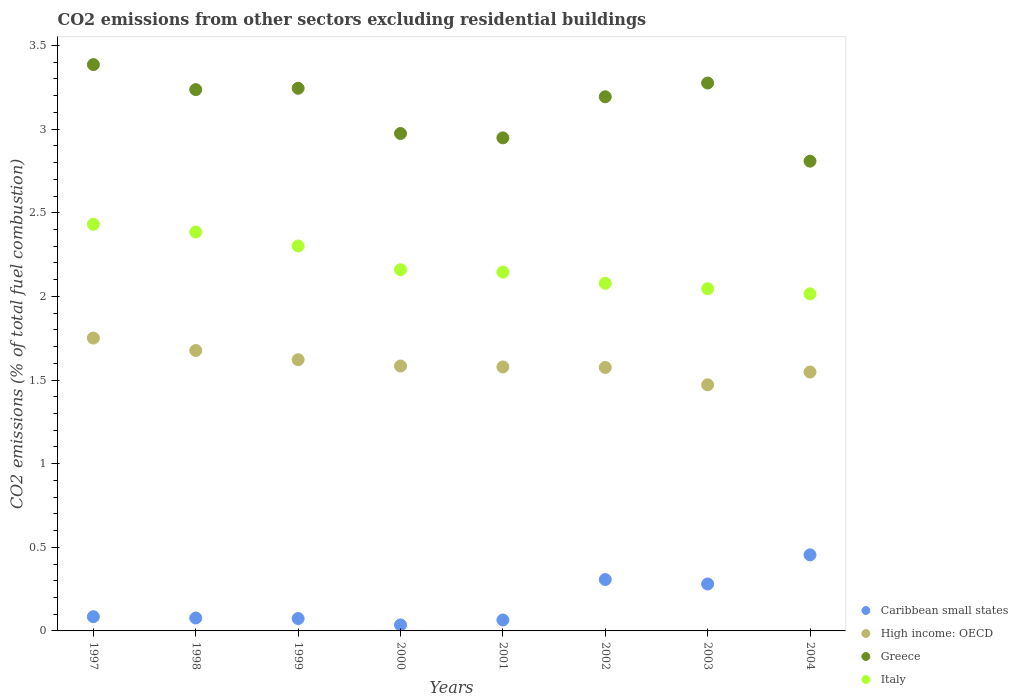Is the number of dotlines equal to the number of legend labels?
Offer a very short reply. Yes. What is the total CO2 emitted in Caribbean small states in 2001?
Provide a succinct answer. 0.07. Across all years, what is the maximum total CO2 emitted in Caribbean small states?
Provide a succinct answer. 0.45. Across all years, what is the minimum total CO2 emitted in Greece?
Your response must be concise. 2.81. In which year was the total CO2 emitted in Greece maximum?
Provide a succinct answer. 1997. In which year was the total CO2 emitted in Caribbean small states minimum?
Keep it short and to the point. 2000. What is the total total CO2 emitted in Greece in the graph?
Make the answer very short. 25.07. What is the difference between the total CO2 emitted in Greece in 2002 and that in 2003?
Offer a terse response. -0.08. What is the difference between the total CO2 emitted in High income: OECD in 1999 and the total CO2 emitted in Italy in 2000?
Ensure brevity in your answer.  -0.54. What is the average total CO2 emitted in High income: OECD per year?
Ensure brevity in your answer.  1.6. In the year 2004, what is the difference between the total CO2 emitted in High income: OECD and total CO2 emitted in Greece?
Keep it short and to the point. -1.26. What is the ratio of the total CO2 emitted in High income: OECD in 1998 to that in 2002?
Offer a terse response. 1.06. Is the difference between the total CO2 emitted in High income: OECD in 2000 and 2003 greater than the difference between the total CO2 emitted in Greece in 2000 and 2003?
Your answer should be very brief. Yes. What is the difference between the highest and the second highest total CO2 emitted in Italy?
Offer a very short reply. 0.05. What is the difference between the highest and the lowest total CO2 emitted in High income: OECD?
Ensure brevity in your answer.  0.28. Is the total CO2 emitted in Italy strictly less than the total CO2 emitted in High income: OECD over the years?
Provide a succinct answer. No. How many years are there in the graph?
Your answer should be compact. 8. Does the graph contain any zero values?
Provide a short and direct response. No. Does the graph contain grids?
Provide a short and direct response. No. Where does the legend appear in the graph?
Your answer should be compact. Bottom right. How are the legend labels stacked?
Offer a terse response. Vertical. What is the title of the graph?
Provide a short and direct response. CO2 emissions from other sectors excluding residential buildings. What is the label or title of the X-axis?
Give a very brief answer. Years. What is the label or title of the Y-axis?
Your response must be concise. CO2 emissions (% of total fuel combustion). What is the CO2 emissions (% of total fuel combustion) in Caribbean small states in 1997?
Make the answer very short. 0.08. What is the CO2 emissions (% of total fuel combustion) of High income: OECD in 1997?
Your answer should be very brief. 1.75. What is the CO2 emissions (% of total fuel combustion) of Greece in 1997?
Give a very brief answer. 3.39. What is the CO2 emissions (% of total fuel combustion) of Italy in 1997?
Make the answer very short. 2.43. What is the CO2 emissions (% of total fuel combustion) in Caribbean small states in 1998?
Provide a succinct answer. 0.08. What is the CO2 emissions (% of total fuel combustion) of High income: OECD in 1998?
Offer a terse response. 1.68. What is the CO2 emissions (% of total fuel combustion) of Greece in 1998?
Give a very brief answer. 3.24. What is the CO2 emissions (% of total fuel combustion) of Italy in 1998?
Keep it short and to the point. 2.38. What is the CO2 emissions (% of total fuel combustion) of Caribbean small states in 1999?
Your answer should be very brief. 0.07. What is the CO2 emissions (% of total fuel combustion) of High income: OECD in 1999?
Offer a terse response. 1.62. What is the CO2 emissions (% of total fuel combustion) in Greece in 1999?
Your response must be concise. 3.24. What is the CO2 emissions (% of total fuel combustion) of Italy in 1999?
Provide a short and direct response. 2.3. What is the CO2 emissions (% of total fuel combustion) of Caribbean small states in 2000?
Your answer should be compact. 0.04. What is the CO2 emissions (% of total fuel combustion) of High income: OECD in 2000?
Provide a succinct answer. 1.58. What is the CO2 emissions (% of total fuel combustion) of Greece in 2000?
Offer a very short reply. 2.97. What is the CO2 emissions (% of total fuel combustion) of Italy in 2000?
Offer a very short reply. 2.16. What is the CO2 emissions (% of total fuel combustion) in Caribbean small states in 2001?
Your response must be concise. 0.07. What is the CO2 emissions (% of total fuel combustion) of High income: OECD in 2001?
Offer a very short reply. 1.58. What is the CO2 emissions (% of total fuel combustion) in Greece in 2001?
Keep it short and to the point. 2.95. What is the CO2 emissions (% of total fuel combustion) in Italy in 2001?
Offer a very short reply. 2.15. What is the CO2 emissions (% of total fuel combustion) in Caribbean small states in 2002?
Your response must be concise. 0.31. What is the CO2 emissions (% of total fuel combustion) in High income: OECD in 2002?
Give a very brief answer. 1.58. What is the CO2 emissions (% of total fuel combustion) in Greece in 2002?
Make the answer very short. 3.19. What is the CO2 emissions (% of total fuel combustion) of Italy in 2002?
Provide a short and direct response. 2.08. What is the CO2 emissions (% of total fuel combustion) of Caribbean small states in 2003?
Your answer should be very brief. 0.28. What is the CO2 emissions (% of total fuel combustion) of High income: OECD in 2003?
Provide a short and direct response. 1.47. What is the CO2 emissions (% of total fuel combustion) of Greece in 2003?
Give a very brief answer. 3.28. What is the CO2 emissions (% of total fuel combustion) in Italy in 2003?
Your response must be concise. 2.05. What is the CO2 emissions (% of total fuel combustion) of Caribbean small states in 2004?
Provide a short and direct response. 0.45. What is the CO2 emissions (% of total fuel combustion) of High income: OECD in 2004?
Offer a terse response. 1.55. What is the CO2 emissions (% of total fuel combustion) of Greece in 2004?
Provide a short and direct response. 2.81. What is the CO2 emissions (% of total fuel combustion) in Italy in 2004?
Your answer should be very brief. 2.02. Across all years, what is the maximum CO2 emissions (% of total fuel combustion) in Caribbean small states?
Offer a very short reply. 0.45. Across all years, what is the maximum CO2 emissions (% of total fuel combustion) in High income: OECD?
Offer a very short reply. 1.75. Across all years, what is the maximum CO2 emissions (% of total fuel combustion) of Greece?
Ensure brevity in your answer.  3.39. Across all years, what is the maximum CO2 emissions (% of total fuel combustion) in Italy?
Make the answer very short. 2.43. Across all years, what is the minimum CO2 emissions (% of total fuel combustion) in Caribbean small states?
Provide a short and direct response. 0.04. Across all years, what is the minimum CO2 emissions (% of total fuel combustion) in High income: OECD?
Your answer should be very brief. 1.47. Across all years, what is the minimum CO2 emissions (% of total fuel combustion) in Greece?
Ensure brevity in your answer.  2.81. Across all years, what is the minimum CO2 emissions (% of total fuel combustion) in Italy?
Your answer should be compact. 2.02. What is the total CO2 emissions (% of total fuel combustion) of Caribbean small states in the graph?
Give a very brief answer. 1.38. What is the total CO2 emissions (% of total fuel combustion) of High income: OECD in the graph?
Your response must be concise. 12.81. What is the total CO2 emissions (% of total fuel combustion) in Greece in the graph?
Offer a terse response. 25.07. What is the total CO2 emissions (% of total fuel combustion) in Italy in the graph?
Provide a succinct answer. 17.56. What is the difference between the CO2 emissions (% of total fuel combustion) in Caribbean small states in 1997 and that in 1998?
Offer a very short reply. 0.01. What is the difference between the CO2 emissions (% of total fuel combustion) in High income: OECD in 1997 and that in 1998?
Keep it short and to the point. 0.07. What is the difference between the CO2 emissions (% of total fuel combustion) in Greece in 1997 and that in 1998?
Give a very brief answer. 0.15. What is the difference between the CO2 emissions (% of total fuel combustion) of Italy in 1997 and that in 1998?
Your answer should be very brief. 0.05. What is the difference between the CO2 emissions (% of total fuel combustion) of Caribbean small states in 1997 and that in 1999?
Offer a terse response. 0.01. What is the difference between the CO2 emissions (% of total fuel combustion) of High income: OECD in 1997 and that in 1999?
Offer a very short reply. 0.13. What is the difference between the CO2 emissions (% of total fuel combustion) in Greece in 1997 and that in 1999?
Give a very brief answer. 0.14. What is the difference between the CO2 emissions (% of total fuel combustion) in Italy in 1997 and that in 1999?
Make the answer very short. 0.13. What is the difference between the CO2 emissions (% of total fuel combustion) in Caribbean small states in 1997 and that in 2000?
Offer a terse response. 0.05. What is the difference between the CO2 emissions (% of total fuel combustion) in High income: OECD in 1997 and that in 2000?
Make the answer very short. 0.17. What is the difference between the CO2 emissions (% of total fuel combustion) of Greece in 1997 and that in 2000?
Make the answer very short. 0.41. What is the difference between the CO2 emissions (% of total fuel combustion) in Italy in 1997 and that in 2000?
Provide a succinct answer. 0.27. What is the difference between the CO2 emissions (% of total fuel combustion) in Caribbean small states in 1997 and that in 2001?
Your response must be concise. 0.02. What is the difference between the CO2 emissions (% of total fuel combustion) in High income: OECD in 1997 and that in 2001?
Provide a succinct answer. 0.17. What is the difference between the CO2 emissions (% of total fuel combustion) of Greece in 1997 and that in 2001?
Make the answer very short. 0.44. What is the difference between the CO2 emissions (% of total fuel combustion) of Italy in 1997 and that in 2001?
Make the answer very short. 0.29. What is the difference between the CO2 emissions (% of total fuel combustion) of Caribbean small states in 1997 and that in 2002?
Ensure brevity in your answer.  -0.22. What is the difference between the CO2 emissions (% of total fuel combustion) of High income: OECD in 1997 and that in 2002?
Offer a terse response. 0.18. What is the difference between the CO2 emissions (% of total fuel combustion) in Greece in 1997 and that in 2002?
Provide a succinct answer. 0.19. What is the difference between the CO2 emissions (% of total fuel combustion) of Italy in 1997 and that in 2002?
Offer a terse response. 0.35. What is the difference between the CO2 emissions (% of total fuel combustion) of Caribbean small states in 1997 and that in 2003?
Ensure brevity in your answer.  -0.2. What is the difference between the CO2 emissions (% of total fuel combustion) of High income: OECD in 1997 and that in 2003?
Provide a succinct answer. 0.28. What is the difference between the CO2 emissions (% of total fuel combustion) in Greece in 1997 and that in 2003?
Make the answer very short. 0.11. What is the difference between the CO2 emissions (% of total fuel combustion) in Italy in 1997 and that in 2003?
Keep it short and to the point. 0.38. What is the difference between the CO2 emissions (% of total fuel combustion) in Caribbean small states in 1997 and that in 2004?
Keep it short and to the point. -0.37. What is the difference between the CO2 emissions (% of total fuel combustion) of High income: OECD in 1997 and that in 2004?
Provide a succinct answer. 0.2. What is the difference between the CO2 emissions (% of total fuel combustion) of Greece in 1997 and that in 2004?
Provide a short and direct response. 0.58. What is the difference between the CO2 emissions (% of total fuel combustion) of Italy in 1997 and that in 2004?
Keep it short and to the point. 0.42. What is the difference between the CO2 emissions (% of total fuel combustion) of Caribbean small states in 1998 and that in 1999?
Provide a short and direct response. 0. What is the difference between the CO2 emissions (% of total fuel combustion) in High income: OECD in 1998 and that in 1999?
Ensure brevity in your answer.  0.06. What is the difference between the CO2 emissions (% of total fuel combustion) of Greece in 1998 and that in 1999?
Ensure brevity in your answer.  -0.01. What is the difference between the CO2 emissions (% of total fuel combustion) in Italy in 1998 and that in 1999?
Make the answer very short. 0.08. What is the difference between the CO2 emissions (% of total fuel combustion) in Caribbean small states in 1998 and that in 2000?
Offer a terse response. 0.04. What is the difference between the CO2 emissions (% of total fuel combustion) of High income: OECD in 1998 and that in 2000?
Your answer should be very brief. 0.09. What is the difference between the CO2 emissions (% of total fuel combustion) of Greece in 1998 and that in 2000?
Make the answer very short. 0.26. What is the difference between the CO2 emissions (% of total fuel combustion) of Italy in 1998 and that in 2000?
Give a very brief answer. 0.23. What is the difference between the CO2 emissions (% of total fuel combustion) in Caribbean small states in 1998 and that in 2001?
Keep it short and to the point. 0.01. What is the difference between the CO2 emissions (% of total fuel combustion) in High income: OECD in 1998 and that in 2001?
Your response must be concise. 0.1. What is the difference between the CO2 emissions (% of total fuel combustion) in Greece in 1998 and that in 2001?
Make the answer very short. 0.29. What is the difference between the CO2 emissions (% of total fuel combustion) in Italy in 1998 and that in 2001?
Your response must be concise. 0.24. What is the difference between the CO2 emissions (% of total fuel combustion) of Caribbean small states in 1998 and that in 2002?
Give a very brief answer. -0.23. What is the difference between the CO2 emissions (% of total fuel combustion) in High income: OECD in 1998 and that in 2002?
Give a very brief answer. 0.1. What is the difference between the CO2 emissions (% of total fuel combustion) in Greece in 1998 and that in 2002?
Offer a very short reply. 0.04. What is the difference between the CO2 emissions (% of total fuel combustion) in Italy in 1998 and that in 2002?
Offer a very short reply. 0.31. What is the difference between the CO2 emissions (% of total fuel combustion) of Caribbean small states in 1998 and that in 2003?
Provide a succinct answer. -0.2. What is the difference between the CO2 emissions (% of total fuel combustion) of High income: OECD in 1998 and that in 2003?
Provide a short and direct response. 0.21. What is the difference between the CO2 emissions (% of total fuel combustion) of Greece in 1998 and that in 2003?
Ensure brevity in your answer.  -0.04. What is the difference between the CO2 emissions (% of total fuel combustion) of Italy in 1998 and that in 2003?
Your response must be concise. 0.34. What is the difference between the CO2 emissions (% of total fuel combustion) of Caribbean small states in 1998 and that in 2004?
Provide a succinct answer. -0.38. What is the difference between the CO2 emissions (% of total fuel combustion) of High income: OECD in 1998 and that in 2004?
Your response must be concise. 0.13. What is the difference between the CO2 emissions (% of total fuel combustion) of Greece in 1998 and that in 2004?
Provide a short and direct response. 0.43. What is the difference between the CO2 emissions (% of total fuel combustion) of Italy in 1998 and that in 2004?
Offer a terse response. 0.37. What is the difference between the CO2 emissions (% of total fuel combustion) of Caribbean small states in 1999 and that in 2000?
Your response must be concise. 0.04. What is the difference between the CO2 emissions (% of total fuel combustion) in High income: OECD in 1999 and that in 2000?
Offer a terse response. 0.04. What is the difference between the CO2 emissions (% of total fuel combustion) of Greece in 1999 and that in 2000?
Ensure brevity in your answer.  0.27. What is the difference between the CO2 emissions (% of total fuel combustion) of Italy in 1999 and that in 2000?
Your answer should be very brief. 0.14. What is the difference between the CO2 emissions (% of total fuel combustion) in Caribbean small states in 1999 and that in 2001?
Offer a very short reply. 0.01. What is the difference between the CO2 emissions (% of total fuel combustion) in High income: OECD in 1999 and that in 2001?
Provide a short and direct response. 0.04. What is the difference between the CO2 emissions (% of total fuel combustion) of Greece in 1999 and that in 2001?
Offer a terse response. 0.3. What is the difference between the CO2 emissions (% of total fuel combustion) of Italy in 1999 and that in 2001?
Your answer should be compact. 0.16. What is the difference between the CO2 emissions (% of total fuel combustion) of Caribbean small states in 1999 and that in 2002?
Provide a succinct answer. -0.23. What is the difference between the CO2 emissions (% of total fuel combustion) of High income: OECD in 1999 and that in 2002?
Make the answer very short. 0.05. What is the difference between the CO2 emissions (% of total fuel combustion) of Greece in 1999 and that in 2002?
Your answer should be compact. 0.05. What is the difference between the CO2 emissions (% of total fuel combustion) of Italy in 1999 and that in 2002?
Your answer should be compact. 0.22. What is the difference between the CO2 emissions (% of total fuel combustion) in Caribbean small states in 1999 and that in 2003?
Provide a succinct answer. -0.21. What is the difference between the CO2 emissions (% of total fuel combustion) of High income: OECD in 1999 and that in 2003?
Ensure brevity in your answer.  0.15. What is the difference between the CO2 emissions (% of total fuel combustion) of Greece in 1999 and that in 2003?
Your answer should be compact. -0.03. What is the difference between the CO2 emissions (% of total fuel combustion) in Italy in 1999 and that in 2003?
Your response must be concise. 0.26. What is the difference between the CO2 emissions (% of total fuel combustion) in Caribbean small states in 1999 and that in 2004?
Make the answer very short. -0.38. What is the difference between the CO2 emissions (% of total fuel combustion) of High income: OECD in 1999 and that in 2004?
Your response must be concise. 0.07. What is the difference between the CO2 emissions (% of total fuel combustion) of Greece in 1999 and that in 2004?
Ensure brevity in your answer.  0.44. What is the difference between the CO2 emissions (% of total fuel combustion) in Italy in 1999 and that in 2004?
Make the answer very short. 0.29. What is the difference between the CO2 emissions (% of total fuel combustion) of Caribbean small states in 2000 and that in 2001?
Your answer should be very brief. -0.03. What is the difference between the CO2 emissions (% of total fuel combustion) in High income: OECD in 2000 and that in 2001?
Keep it short and to the point. 0.01. What is the difference between the CO2 emissions (% of total fuel combustion) in Greece in 2000 and that in 2001?
Keep it short and to the point. 0.03. What is the difference between the CO2 emissions (% of total fuel combustion) in Italy in 2000 and that in 2001?
Offer a very short reply. 0.01. What is the difference between the CO2 emissions (% of total fuel combustion) of Caribbean small states in 2000 and that in 2002?
Your answer should be compact. -0.27. What is the difference between the CO2 emissions (% of total fuel combustion) of High income: OECD in 2000 and that in 2002?
Ensure brevity in your answer.  0.01. What is the difference between the CO2 emissions (% of total fuel combustion) in Greece in 2000 and that in 2002?
Offer a terse response. -0.22. What is the difference between the CO2 emissions (% of total fuel combustion) in Italy in 2000 and that in 2002?
Ensure brevity in your answer.  0.08. What is the difference between the CO2 emissions (% of total fuel combustion) in Caribbean small states in 2000 and that in 2003?
Your answer should be very brief. -0.24. What is the difference between the CO2 emissions (% of total fuel combustion) in High income: OECD in 2000 and that in 2003?
Give a very brief answer. 0.11. What is the difference between the CO2 emissions (% of total fuel combustion) in Greece in 2000 and that in 2003?
Make the answer very short. -0.3. What is the difference between the CO2 emissions (% of total fuel combustion) in Italy in 2000 and that in 2003?
Provide a short and direct response. 0.11. What is the difference between the CO2 emissions (% of total fuel combustion) in Caribbean small states in 2000 and that in 2004?
Offer a terse response. -0.42. What is the difference between the CO2 emissions (% of total fuel combustion) in High income: OECD in 2000 and that in 2004?
Ensure brevity in your answer.  0.04. What is the difference between the CO2 emissions (% of total fuel combustion) in Greece in 2000 and that in 2004?
Your answer should be compact. 0.17. What is the difference between the CO2 emissions (% of total fuel combustion) of Italy in 2000 and that in 2004?
Offer a very short reply. 0.14. What is the difference between the CO2 emissions (% of total fuel combustion) in Caribbean small states in 2001 and that in 2002?
Offer a very short reply. -0.24. What is the difference between the CO2 emissions (% of total fuel combustion) of High income: OECD in 2001 and that in 2002?
Offer a very short reply. 0. What is the difference between the CO2 emissions (% of total fuel combustion) of Greece in 2001 and that in 2002?
Your answer should be very brief. -0.25. What is the difference between the CO2 emissions (% of total fuel combustion) of Italy in 2001 and that in 2002?
Your answer should be compact. 0.07. What is the difference between the CO2 emissions (% of total fuel combustion) in Caribbean small states in 2001 and that in 2003?
Provide a short and direct response. -0.22. What is the difference between the CO2 emissions (% of total fuel combustion) in High income: OECD in 2001 and that in 2003?
Provide a succinct answer. 0.11. What is the difference between the CO2 emissions (% of total fuel combustion) of Greece in 2001 and that in 2003?
Provide a short and direct response. -0.33. What is the difference between the CO2 emissions (% of total fuel combustion) in Italy in 2001 and that in 2003?
Keep it short and to the point. 0.1. What is the difference between the CO2 emissions (% of total fuel combustion) of Caribbean small states in 2001 and that in 2004?
Provide a short and direct response. -0.39. What is the difference between the CO2 emissions (% of total fuel combustion) in High income: OECD in 2001 and that in 2004?
Your answer should be very brief. 0.03. What is the difference between the CO2 emissions (% of total fuel combustion) in Greece in 2001 and that in 2004?
Make the answer very short. 0.14. What is the difference between the CO2 emissions (% of total fuel combustion) of Italy in 2001 and that in 2004?
Make the answer very short. 0.13. What is the difference between the CO2 emissions (% of total fuel combustion) in Caribbean small states in 2002 and that in 2003?
Offer a very short reply. 0.03. What is the difference between the CO2 emissions (% of total fuel combustion) of High income: OECD in 2002 and that in 2003?
Offer a very short reply. 0.1. What is the difference between the CO2 emissions (% of total fuel combustion) in Greece in 2002 and that in 2003?
Make the answer very short. -0.08. What is the difference between the CO2 emissions (% of total fuel combustion) in Italy in 2002 and that in 2003?
Provide a succinct answer. 0.03. What is the difference between the CO2 emissions (% of total fuel combustion) in Caribbean small states in 2002 and that in 2004?
Offer a terse response. -0.15. What is the difference between the CO2 emissions (% of total fuel combustion) in High income: OECD in 2002 and that in 2004?
Your answer should be very brief. 0.03. What is the difference between the CO2 emissions (% of total fuel combustion) of Greece in 2002 and that in 2004?
Offer a very short reply. 0.39. What is the difference between the CO2 emissions (% of total fuel combustion) in Italy in 2002 and that in 2004?
Your response must be concise. 0.06. What is the difference between the CO2 emissions (% of total fuel combustion) of Caribbean small states in 2003 and that in 2004?
Your answer should be very brief. -0.17. What is the difference between the CO2 emissions (% of total fuel combustion) in High income: OECD in 2003 and that in 2004?
Give a very brief answer. -0.08. What is the difference between the CO2 emissions (% of total fuel combustion) of Greece in 2003 and that in 2004?
Keep it short and to the point. 0.47. What is the difference between the CO2 emissions (% of total fuel combustion) in Italy in 2003 and that in 2004?
Offer a terse response. 0.03. What is the difference between the CO2 emissions (% of total fuel combustion) of Caribbean small states in 1997 and the CO2 emissions (% of total fuel combustion) of High income: OECD in 1998?
Ensure brevity in your answer.  -1.59. What is the difference between the CO2 emissions (% of total fuel combustion) in Caribbean small states in 1997 and the CO2 emissions (% of total fuel combustion) in Greece in 1998?
Ensure brevity in your answer.  -3.15. What is the difference between the CO2 emissions (% of total fuel combustion) of Caribbean small states in 1997 and the CO2 emissions (% of total fuel combustion) of Italy in 1998?
Keep it short and to the point. -2.3. What is the difference between the CO2 emissions (% of total fuel combustion) in High income: OECD in 1997 and the CO2 emissions (% of total fuel combustion) in Greece in 1998?
Offer a terse response. -1.49. What is the difference between the CO2 emissions (% of total fuel combustion) of High income: OECD in 1997 and the CO2 emissions (% of total fuel combustion) of Italy in 1998?
Provide a succinct answer. -0.63. What is the difference between the CO2 emissions (% of total fuel combustion) in Greece in 1997 and the CO2 emissions (% of total fuel combustion) in Italy in 1998?
Your response must be concise. 1. What is the difference between the CO2 emissions (% of total fuel combustion) of Caribbean small states in 1997 and the CO2 emissions (% of total fuel combustion) of High income: OECD in 1999?
Make the answer very short. -1.54. What is the difference between the CO2 emissions (% of total fuel combustion) of Caribbean small states in 1997 and the CO2 emissions (% of total fuel combustion) of Greece in 1999?
Provide a succinct answer. -3.16. What is the difference between the CO2 emissions (% of total fuel combustion) in Caribbean small states in 1997 and the CO2 emissions (% of total fuel combustion) in Italy in 1999?
Ensure brevity in your answer.  -2.22. What is the difference between the CO2 emissions (% of total fuel combustion) in High income: OECD in 1997 and the CO2 emissions (% of total fuel combustion) in Greece in 1999?
Keep it short and to the point. -1.49. What is the difference between the CO2 emissions (% of total fuel combustion) in High income: OECD in 1997 and the CO2 emissions (% of total fuel combustion) in Italy in 1999?
Keep it short and to the point. -0.55. What is the difference between the CO2 emissions (% of total fuel combustion) in Greece in 1997 and the CO2 emissions (% of total fuel combustion) in Italy in 1999?
Your answer should be very brief. 1.08. What is the difference between the CO2 emissions (% of total fuel combustion) of Caribbean small states in 1997 and the CO2 emissions (% of total fuel combustion) of High income: OECD in 2000?
Offer a terse response. -1.5. What is the difference between the CO2 emissions (% of total fuel combustion) in Caribbean small states in 1997 and the CO2 emissions (% of total fuel combustion) in Greece in 2000?
Provide a succinct answer. -2.89. What is the difference between the CO2 emissions (% of total fuel combustion) in Caribbean small states in 1997 and the CO2 emissions (% of total fuel combustion) in Italy in 2000?
Provide a succinct answer. -2.07. What is the difference between the CO2 emissions (% of total fuel combustion) in High income: OECD in 1997 and the CO2 emissions (% of total fuel combustion) in Greece in 2000?
Ensure brevity in your answer.  -1.22. What is the difference between the CO2 emissions (% of total fuel combustion) in High income: OECD in 1997 and the CO2 emissions (% of total fuel combustion) in Italy in 2000?
Offer a very short reply. -0.41. What is the difference between the CO2 emissions (% of total fuel combustion) in Greece in 1997 and the CO2 emissions (% of total fuel combustion) in Italy in 2000?
Your response must be concise. 1.23. What is the difference between the CO2 emissions (% of total fuel combustion) of Caribbean small states in 1997 and the CO2 emissions (% of total fuel combustion) of High income: OECD in 2001?
Provide a succinct answer. -1.49. What is the difference between the CO2 emissions (% of total fuel combustion) in Caribbean small states in 1997 and the CO2 emissions (% of total fuel combustion) in Greece in 2001?
Provide a succinct answer. -2.86. What is the difference between the CO2 emissions (% of total fuel combustion) of Caribbean small states in 1997 and the CO2 emissions (% of total fuel combustion) of Italy in 2001?
Give a very brief answer. -2.06. What is the difference between the CO2 emissions (% of total fuel combustion) of High income: OECD in 1997 and the CO2 emissions (% of total fuel combustion) of Greece in 2001?
Provide a succinct answer. -1.2. What is the difference between the CO2 emissions (% of total fuel combustion) of High income: OECD in 1997 and the CO2 emissions (% of total fuel combustion) of Italy in 2001?
Offer a very short reply. -0.39. What is the difference between the CO2 emissions (% of total fuel combustion) in Greece in 1997 and the CO2 emissions (% of total fuel combustion) in Italy in 2001?
Provide a short and direct response. 1.24. What is the difference between the CO2 emissions (% of total fuel combustion) in Caribbean small states in 1997 and the CO2 emissions (% of total fuel combustion) in High income: OECD in 2002?
Your response must be concise. -1.49. What is the difference between the CO2 emissions (% of total fuel combustion) of Caribbean small states in 1997 and the CO2 emissions (% of total fuel combustion) of Greece in 2002?
Your answer should be compact. -3.11. What is the difference between the CO2 emissions (% of total fuel combustion) in Caribbean small states in 1997 and the CO2 emissions (% of total fuel combustion) in Italy in 2002?
Your response must be concise. -1.99. What is the difference between the CO2 emissions (% of total fuel combustion) of High income: OECD in 1997 and the CO2 emissions (% of total fuel combustion) of Greece in 2002?
Your response must be concise. -1.44. What is the difference between the CO2 emissions (% of total fuel combustion) in High income: OECD in 1997 and the CO2 emissions (% of total fuel combustion) in Italy in 2002?
Keep it short and to the point. -0.33. What is the difference between the CO2 emissions (% of total fuel combustion) of Greece in 1997 and the CO2 emissions (% of total fuel combustion) of Italy in 2002?
Your response must be concise. 1.31. What is the difference between the CO2 emissions (% of total fuel combustion) in Caribbean small states in 1997 and the CO2 emissions (% of total fuel combustion) in High income: OECD in 2003?
Your response must be concise. -1.39. What is the difference between the CO2 emissions (% of total fuel combustion) of Caribbean small states in 1997 and the CO2 emissions (% of total fuel combustion) of Greece in 2003?
Make the answer very short. -3.19. What is the difference between the CO2 emissions (% of total fuel combustion) in Caribbean small states in 1997 and the CO2 emissions (% of total fuel combustion) in Italy in 2003?
Offer a terse response. -1.96. What is the difference between the CO2 emissions (% of total fuel combustion) of High income: OECD in 1997 and the CO2 emissions (% of total fuel combustion) of Greece in 2003?
Ensure brevity in your answer.  -1.52. What is the difference between the CO2 emissions (% of total fuel combustion) in High income: OECD in 1997 and the CO2 emissions (% of total fuel combustion) in Italy in 2003?
Your response must be concise. -0.3. What is the difference between the CO2 emissions (% of total fuel combustion) in Greece in 1997 and the CO2 emissions (% of total fuel combustion) in Italy in 2003?
Ensure brevity in your answer.  1.34. What is the difference between the CO2 emissions (% of total fuel combustion) in Caribbean small states in 1997 and the CO2 emissions (% of total fuel combustion) in High income: OECD in 2004?
Provide a succinct answer. -1.46. What is the difference between the CO2 emissions (% of total fuel combustion) of Caribbean small states in 1997 and the CO2 emissions (% of total fuel combustion) of Greece in 2004?
Ensure brevity in your answer.  -2.72. What is the difference between the CO2 emissions (% of total fuel combustion) in Caribbean small states in 1997 and the CO2 emissions (% of total fuel combustion) in Italy in 2004?
Offer a very short reply. -1.93. What is the difference between the CO2 emissions (% of total fuel combustion) of High income: OECD in 1997 and the CO2 emissions (% of total fuel combustion) of Greece in 2004?
Provide a short and direct response. -1.06. What is the difference between the CO2 emissions (% of total fuel combustion) of High income: OECD in 1997 and the CO2 emissions (% of total fuel combustion) of Italy in 2004?
Offer a terse response. -0.26. What is the difference between the CO2 emissions (% of total fuel combustion) of Greece in 1997 and the CO2 emissions (% of total fuel combustion) of Italy in 2004?
Keep it short and to the point. 1.37. What is the difference between the CO2 emissions (% of total fuel combustion) in Caribbean small states in 1998 and the CO2 emissions (% of total fuel combustion) in High income: OECD in 1999?
Your answer should be very brief. -1.54. What is the difference between the CO2 emissions (% of total fuel combustion) in Caribbean small states in 1998 and the CO2 emissions (% of total fuel combustion) in Greece in 1999?
Keep it short and to the point. -3.17. What is the difference between the CO2 emissions (% of total fuel combustion) of Caribbean small states in 1998 and the CO2 emissions (% of total fuel combustion) of Italy in 1999?
Offer a very short reply. -2.22. What is the difference between the CO2 emissions (% of total fuel combustion) of High income: OECD in 1998 and the CO2 emissions (% of total fuel combustion) of Greece in 1999?
Give a very brief answer. -1.57. What is the difference between the CO2 emissions (% of total fuel combustion) of High income: OECD in 1998 and the CO2 emissions (% of total fuel combustion) of Italy in 1999?
Ensure brevity in your answer.  -0.62. What is the difference between the CO2 emissions (% of total fuel combustion) in Greece in 1998 and the CO2 emissions (% of total fuel combustion) in Italy in 1999?
Ensure brevity in your answer.  0.93. What is the difference between the CO2 emissions (% of total fuel combustion) of Caribbean small states in 1998 and the CO2 emissions (% of total fuel combustion) of High income: OECD in 2000?
Ensure brevity in your answer.  -1.51. What is the difference between the CO2 emissions (% of total fuel combustion) of Caribbean small states in 1998 and the CO2 emissions (% of total fuel combustion) of Greece in 2000?
Make the answer very short. -2.9. What is the difference between the CO2 emissions (% of total fuel combustion) of Caribbean small states in 1998 and the CO2 emissions (% of total fuel combustion) of Italy in 2000?
Give a very brief answer. -2.08. What is the difference between the CO2 emissions (% of total fuel combustion) in High income: OECD in 1998 and the CO2 emissions (% of total fuel combustion) in Greece in 2000?
Your answer should be compact. -1.3. What is the difference between the CO2 emissions (% of total fuel combustion) of High income: OECD in 1998 and the CO2 emissions (% of total fuel combustion) of Italy in 2000?
Provide a succinct answer. -0.48. What is the difference between the CO2 emissions (% of total fuel combustion) in Greece in 1998 and the CO2 emissions (% of total fuel combustion) in Italy in 2000?
Provide a short and direct response. 1.08. What is the difference between the CO2 emissions (% of total fuel combustion) of Caribbean small states in 1998 and the CO2 emissions (% of total fuel combustion) of High income: OECD in 2001?
Ensure brevity in your answer.  -1.5. What is the difference between the CO2 emissions (% of total fuel combustion) in Caribbean small states in 1998 and the CO2 emissions (% of total fuel combustion) in Greece in 2001?
Provide a short and direct response. -2.87. What is the difference between the CO2 emissions (% of total fuel combustion) in Caribbean small states in 1998 and the CO2 emissions (% of total fuel combustion) in Italy in 2001?
Ensure brevity in your answer.  -2.07. What is the difference between the CO2 emissions (% of total fuel combustion) in High income: OECD in 1998 and the CO2 emissions (% of total fuel combustion) in Greece in 2001?
Your answer should be compact. -1.27. What is the difference between the CO2 emissions (% of total fuel combustion) of High income: OECD in 1998 and the CO2 emissions (% of total fuel combustion) of Italy in 2001?
Provide a succinct answer. -0.47. What is the difference between the CO2 emissions (% of total fuel combustion) of Greece in 1998 and the CO2 emissions (% of total fuel combustion) of Italy in 2001?
Your response must be concise. 1.09. What is the difference between the CO2 emissions (% of total fuel combustion) in Caribbean small states in 1998 and the CO2 emissions (% of total fuel combustion) in High income: OECD in 2002?
Offer a terse response. -1.5. What is the difference between the CO2 emissions (% of total fuel combustion) of Caribbean small states in 1998 and the CO2 emissions (% of total fuel combustion) of Greece in 2002?
Your answer should be very brief. -3.12. What is the difference between the CO2 emissions (% of total fuel combustion) of Caribbean small states in 1998 and the CO2 emissions (% of total fuel combustion) of Italy in 2002?
Your response must be concise. -2. What is the difference between the CO2 emissions (% of total fuel combustion) of High income: OECD in 1998 and the CO2 emissions (% of total fuel combustion) of Greece in 2002?
Provide a succinct answer. -1.52. What is the difference between the CO2 emissions (% of total fuel combustion) of High income: OECD in 1998 and the CO2 emissions (% of total fuel combustion) of Italy in 2002?
Your answer should be very brief. -0.4. What is the difference between the CO2 emissions (% of total fuel combustion) of Greece in 1998 and the CO2 emissions (% of total fuel combustion) of Italy in 2002?
Your response must be concise. 1.16. What is the difference between the CO2 emissions (% of total fuel combustion) in Caribbean small states in 1998 and the CO2 emissions (% of total fuel combustion) in High income: OECD in 2003?
Offer a very short reply. -1.39. What is the difference between the CO2 emissions (% of total fuel combustion) of Caribbean small states in 1998 and the CO2 emissions (% of total fuel combustion) of Greece in 2003?
Make the answer very short. -3.2. What is the difference between the CO2 emissions (% of total fuel combustion) in Caribbean small states in 1998 and the CO2 emissions (% of total fuel combustion) in Italy in 2003?
Offer a terse response. -1.97. What is the difference between the CO2 emissions (% of total fuel combustion) of High income: OECD in 1998 and the CO2 emissions (% of total fuel combustion) of Greece in 2003?
Make the answer very short. -1.6. What is the difference between the CO2 emissions (% of total fuel combustion) of High income: OECD in 1998 and the CO2 emissions (% of total fuel combustion) of Italy in 2003?
Provide a succinct answer. -0.37. What is the difference between the CO2 emissions (% of total fuel combustion) of Greece in 1998 and the CO2 emissions (% of total fuel combustion) of Italy in 2003?
Provide a short and direct response. 1.19. What is the difference between the CO2 emissions (% of total fuel combustion) of Caribbean small states in 1998 and the CO2 emissions (% of total fuel combustion) of High income: OECD in 2004?
Give a very brief answer. -1.47. What is the difference between the CO2 emissions (% of total fuel combustion) in Caribbean small states in 1998 and the CO2 emissions (% of total fuel combustion) in Greece in 2004?
Make the answer very short. -2.73. What is the difference between the CO2 emissions (% of total fuel combustion) in Caribbean small states in 1998 and the CO2 emissions (% of total fuel combustion) in Italy in 2004?
Offer a terse response. -1.94. What is the difference between the CO2 emissions (% of total fuel combustion) of High income: OECD in 1998 and the CO2 emissions (% of total fuel combustion) of Greece in 2004?
Offer a very short reply. -1.13. What is the difference between the CO2 emissions (% of total fuel combustion) in High income: OECD in 1998 and the CO2 emissions (% of total fuel combustion) in Italy in 2004?
Give a very brief answer. -0.34. What is the difference between the CO2 emissions (% of total fuel combustion) in Greece in 1998 and the CO2 emissions (% of total fuel combustion) in Italy in 2004?
Provide a short and direct response. 1.22. What is the difference between the CO2 emissions (% of total fuel combustion) in Caribbean small states in 1999 and the CO2 emissions (% of total fuel combustion) in High income: OECD in 2000?
Your answer should be very brief. -1.51. What is the difference between the CO2 emissions (% of total fuel combustion) in Caribbean small states in 1999 and the CO2 emissions (% of total fuel combustion) in Greece in 2000?
Ensure brevity in your answer.  -2.9. What is the difference between the CO2 emissions (% of total fuel combustion) in Caribbean small states in 1999 and the CO2 emissions (% of total fuel combustion) in Italy in 2000?
Provide a succinct answer. -2.09. What is the difference between the CO2 emissions (% of total fuel combustion) of High income: OECD in 1999 and the CO2 emissions (% of total fuel combustion) of Greece in 2000?
Offer a terse response. -1.35. What is the difference between the CO2 emissions (% of total fuel combustion) of High income: OECD in 1999 and the CO2 emissions (% of total fuel combustion) of Italy in 2000?
Offer a very short reply. -0.54. What is the difference between the CO2 emissions (% of total fuel combustion) of Greece in 1999 and the CO2 emissions (% of total fuel combustion) of Italy in 2000?
Your response must be concise. 1.08. What is the difference between the CO2 emissions (% of total fuel combustion) in Caribbean small states in 1999 and the CO2 emissions (% of total fuel combustion) in High income: OECD in 2001?
Give a very brief answer. -1.5. What is the difference between the CO2 emissions (% of total fuel combustion) in Caribbean small states in 1999 and the CO2 emissions (% of total fuel combustion) in Greece in 2001?
Keep it short and to the point. -2.87. What is the difference between the CO2 emissions (% of total fuel combustion) in Caribbean small states in 1999 and the CO2 emissions (% of total fuel combustion) in Italy in 2001?
Offer a terse response. -2.07. What is the difference between the CO2 emissions (% of total fuel combustion) in High income: OECD in 1999 and the CO2 emissions (% of total fuel combustion) in Greece in 2001?
Provide a short and direct response. -1.33. What is the difference between the CO2 emissions (% of total fuel combustion) of High income: OECD in 1999 and the CO2 emissions (% of total fuel combustion) of Italy in 2001?
Your response must be concise. -0.52. What is the difference between the CO2 emissions (% of total fuel combustion) in Greece in 1999 and the CO2 emissions (% of total fuel combustion) in Italy in 2001?
Offer a very short reply. 1.1. What is the difference between the CO2 emissions (% of total fuel combustion) of Caribbean small states in 1999 and the CO2 emissions (% of total fuel combustion) of High income: OECD in 2002?
Keep it short and to the point. -1.5. What is the difference between the CO2 emissions (% of total fuel combustion) of Caribbean small states in 1999 and the CO2 emissions (% of total fuel combustion) of Greece in 2002?
Provide a succinct answer. -3.12. What is the difference between the CO2 emissions (% of total fuel combustion) of Caribbean small states in 1999 and the CO2 emissions (% of total fuel combustion) of Italy in 2002?
Your response must be concise. -2. What is the difference between the CO2 emissions (% of total fuel combustion) in High income: OECD in 1999 and the CO2 emissions (% of total fuel combustion) in Greece in 2002?
Give a very brief answer. -1.57. What is the difference between the CO2 emissions (% of total fuel combustion) in High income: OECD in 1999 and the CO2 emissions (% of total fuel combustion) in Italy in 2002?
Provide a succinct answer. -0.46. What is the difference between the CO2 emissions (% of total fuel combustion) in Greece in 1999 and the CO2 emissions (% of total fuel combustion) in Italy in 2002?
Make the answer very short. 1.17. What is the difference between the CO2 emissions (% of total fuel combustion) of Caribbean small states in 1999 and the CO2 emissions (% of total fuel combustion) of High income: OECD in 2003?
Give a very brief answer. -1.4. What is the difference between the CO2 emissions (% of total fuel combustion) of Caribbean small states in 1999 and the CO2 emissions (% of total fuel combustion) of Greece in 2003?
Offer a terse response. -3.2. What is the difference between the CO2 emissions (% of total fuel combustion) of Caribbean small states in 1999 and the CO2 emissions (% of total fuel combustion) of Italy in 2003?
Provide a short and direct response. -1.97. What is the difference between the CO2 emissions (% of total fuel combustion) of High income: OECD in 1999 and the CO2 emissions (% of total fuel combustion) of Greece in 2003?
Offer a very short reply. -1.65. What is the difference between the CO2 emissions (% of total fuel combustion) in High income: OECD in 1999 and the CO2 emissions (% of total fuel combustion) in Italy in 2003?
Keep it short and to the point. -0.42. What is the difference between the CO2 emissions (% of total fuel combustion) of Greece in 1999 and the CO2 emissions (% of total fuel combustion) of Italy in 2003?
Offer a terse response. 1.2. What is the difference between the CO2 emissions (% of total fuel combustion) of Caribbean small states in 1999 and the CO2 emissions (% of total fuel combustion) of High income: OECD in 2004?
Keep it short and to the point. -1.47. What is the difference between the CO2 emissions (% of total fuel combustion) in Caribbean small states in 1999 and the CO2 emissions (% of total fuel combustion) in Greece in 2004?
Your answer should be very brief. -2.73. What is the difference between the CO2 emissions (% of total fuel combustion) in Caribbean small states in 1999 and the CO2 emissions (% of total fuel combustion) in Italy in 2004?
Offer a terse response. -1.94. What is the difference between the CO2 emissions (% of total fuel combustion) of High income: OECD in 1999 and the CO2 emissions (% of total fuel combustion) of Greece in 2004?
Your answer should be compact. -1.19. What is the difference between the CO2 emissions (% of total fuel combustion) of High income: OECD in 1999 and the CO2 emissions (% of total fuel combustion) of Italy in 2004?
Keep it short and to the point. -0.39. What is the difference between the CO2 emissions (% of total fuel combustion) in Greece in 1999 and the CO2 emissions (% of total fuel combustion) in Italy in 2004?
Offer a terse response. 1.23. What is the difference between the CO2 emissions (% of total fuel combustion) of Caribbean small states in 2000 and the CO2 emissions (% of total fuel combustion) of High income: OECD in 2001?
Offer a very short reply. -1.54. What is the difference between the CO2 emissions (% of total fuel combustion) in Caribbean small states in 2000 and the CO2 emissions (% of total fuel combustion) in Greece in 2001?
Offer a terse response. -2.91. What is the difference between the CO2 emissions (% of total fuel combustion) in Caribbean small states in 2000 and the CO2 emissions (% of total fuel combustion) in Italy in 2001?
Your answer should be very brief. -2.11. What is the difference between the CO2 emissions (% of total fuel combustion) in High income: OECD in 2000 and the CO2 emissions (% of total fuel combustion) in Greece in 2001?
Keep it short and to the point. -1.36. What is the difference between the CO2 emissions (% of total fuel combustion) in High income: OECD in 2000 and the CO2 emissions (% of total fuel combustion) in Italy in 2001?
Your answer should be compact. -0.56. What is the difference between the CO2 emissions (% of total fuel combustion) in Greece in 2000 and the CO2 emissions (% of total fuel combustion) in Italy in 2001?
Give a very brief answer. 0.83. What is the difference between the CO2 emissions (% of total fuel combustion) in Caribbean small states in 2000 and the CO2 emissions (% of total fuel combustion) in High income: OECD in 2002?
Offer a very short reply. -1.54. What is the difference between the CO2 emissions (% of total fuel combustion) in Caribbean small states in 2000 and the CO2 emissions (% of total fuel combustion) in Greece in 2002?
Make the answer very short. -3.16. What is the difference between the CO2 emissions (% of total fuel combustion) of Caribbean small states in 2000 and the CO2 emissions (% of total fuel combustion) of Italy in 2002?
Your answer should be very brief. -2.04. What is the difference between the CO2 emissions (% of total fuel combustion) in High income: OECD in 2000 and the CO2 emissions (% of total fuel combustion) in Greece in 2002?
Keep it short and to the point. -1.61. What is the difference between the CO2 emissions (% of total fuel combustion) in High income: OECD in 2000 and the CO2 emissions (% of total fuel combustion) in Italy in 2002?
Give a very brief answer. -0.49. What is the difference between the CO2 emissions (% of total fuel combustion) in Greece in 2000 and the CO2 emissions (% of total fuel combustion) in Italy in 2002?
Your answer should be compact. 0.9. What is the difference between the CO2 emissions (% of total fuel combustion) in Caribbean small states in 2000 and the CO2 emissions (% of total fuel combustion) in High income: OECD in 2003?
Give a very brief answer. -1.44. What is the difference between the CO2 emissions (% of total fuel combustion) in Caribbean small states in 2000 and the CO2 emissions (% of total fuel combustion) in Greece in 2003?
Offer a terse response. -3.24. What is the difference between the CO2 emissions (% of total fuel combustion) in Caribbean small states in 2000 and the CO2 emissions (% of total fuel combustion) in Italy in 2003?
Give a very brief answer. -2.01. What is the difference between the CO2 emissions (% of total fuel combustion) in High income: OECD in 2000 and the CO2 emissions (% of total fuel combustion) in Greece in 2003?
Ensure brevity in your answer.  -1.69. What is the difference between the CO2 emissions (% of total fuel combustion) in High income: OECD in 2000 and the CO2 emissions (% of total fuel combustion) in Italy in 2003?
Ensure brevity in your answer.  -0.46. What is the difference between the CO2 emissions (% of total fuel combustion) of Greece in 2000 and the CO2 emissions (% of total fuel combustion) of Italy in 2003?
Give a very brief answer. 0.93. What is the difference between the CO2 emissions (% of total fuel combustion) of Caribbean small states in 2000 and the CO2 emissions (% of total fuel combustion) of High income: OECD in 2004?
Offer a terse response. -1.51. What is the difference between the CO2 emissions (% of total fuel combustion) in Caribbean small states in 2000 and the CO2 emissions (% of total fuel combustion) in Greece in 2004?
Offer a very short reply. -2.77. What is the difference between the CO2 emissions (% of total fuel combustion) of Caribbean small states in 2000 and the CO2 emissions (% of total fuel combustion) of Italy in 2004?
Your answer should be compact. -1.98. What is the difference between the CO2 emissions (% of total fuel combustion) of High income: OECD in 2000 and the CO2 emissions (% of total fuel combustion) of Greece in 2004?
Provide a succinct answer. -1.22. What is the difference between the CO2 emissions (% of total fuel combustion) of High income: OECD in 2000 and the CO2 emissions (% of total fuel combustion) of Italy in 2004?
Your answer should be very brief. -0.43. What is the difference between the CO2 emissions (% of total fuel combustion) of Greece in 2000 and the CO2 emissions (% of total fuel combustion) of Italy in 2004?
Offer a terse response. 0.96. What is the difference between the CO2 emissions (% of total fuel combustion) in Caribbean small states in 2001 and the CO2 emissions (% of total fuel combustion) in High income: OECD in 2002?
Your response must be concise. -1.51. What is the difference between the CO2 emissions (% of total fuel combustion) of Caribbean small states in 2001 and the CO2 emissions (% of total fuel combustion) of Greece in 2002?
Provide a succinct answer. -3.13. What is the difference between the CO2 emissions (% of total fuel combustion) of Caribbean small states in 2001 and the CO2 emissions (% of total fuel combustion) of Italy in 2002?
Provide a short and direct response. -2.01. What is the difference between the CO2 emissions (% of total fuel combustion) of High income: OECD in 2001 and the CO2 emissions (% of total fuel combustion) of Greece in 2002?
Keep it short and to the point. -1.62. What is the difference between the CO2 emissions (% of total fuel combustion) in High income: OECD in 2001 and the CO2 emissions (% of total fuel combustion) in Italy in 2002?
Give a very brief answer. -0.5. What is the difference between the CO2 emissions (% of total fuel combustion) of Greece in 2001 and the CO2 emissions (% of total fuel combustion) of Italy in 2002?
Keep it short and to the point. 0.87. What is the difference between the CO2 emissions (% of total fuel combustion) of Caribbean small states in 2001 and the CO2 emissions (% of total fuel combustion) of High income: OECD in 2003?
Your response must be concise. -1.41. What is the difference between the CO2 emissions (% of total fuel combustion) in Caribbean small states in 2001 and the CO2 emissions (% of total fuel combustion) in Greece in 2003?
Provide a short and direct response. -3.21. What is the difference between the CO2 emissions (% of total fuel combustion) in Caribbean small states in 2001 and the CO2 emissions (% of total fuel combustion) in Italy in 2003?
Give a very brief answer. -1.98. What is the difference between the CO2 emissions (% of total fuel combustion) in High income: OECD in 2001 and the CO2 emissions (% of total fuel combustion) in Greece in 2003?
Provide a succinct answer. -1.7. What is the difference between the CO2 emissions (% of total fuel combustion) of High income: OECD in 2001 and the CO2 emissions (% of total fuel combustion) of Italy in 2003?
Your answer should be compact. -0.47. What is the difference between the CO2 emissions (% of total fuel combustion) of Greece in 2001 and the CO2 emissions (% of total fuel combustion) of Italy in 2003?
Make the answer very short. 0.9. What is the difference between the CO2 emissions (% of total fuel combustion) of Caribbean small states in 2001 and the CO2 emissions (% of total fuel combustion) of High income: OECD in 2004?
Provide a succinct answer. -1.48. What is the difference between the CO2 emissions (% of total fuel combustion) in Caribbean small states in 2001 and the CO2 emissions (% of total fuel combustion) in Greece in 2004?
Your answer should be compact. -2.74. What is the difference between the CO2 emissions (% of total fuel combustion) of Caribbean small states in 2001 and the CO2 emissions (% of total fuel combustion) of Italy in 2004?
Keep it short and to the point. -1.95. What is the difference between the CO2 emissions (% of total fuel combustion) in High income: OECD in 2001 and the CO2 emissions (% of total fuel combustion) in Greece in 2004?
Give a very brief answer. -1.23. What is the difference between the CO2 emissions (% of total fuel combustion) in High income: OECD in 2001 and the CO2 emissions (% of total fuel combustion) in Italy in 2004?
Your answer should be compact. -0.44. What is the difference between the CO2 emissions (% of total fuel combustion) of Greece in 2001 and the CO2 emissions (% of total fuel combustion) of Italy in 2004?
Keep it short and to the point. 0.93. What is the difference between the CO2 emissions (% of total fuel combustion) of Caribbean small states in 2002 and the CO2 emissions (% of total fuel combustion) of High income: OECD in 2003?
Make the answer very short. -1.16. What is the difference between the CO2 emissions (% of total fuel combustion) of Caribbean small states in 2002 and the CO2 emissions (% of total fuel combustion) of Greece in 2003?
Offer a terse response. -2.97. What is the difference between the CO2 emissions (% of total fuel combustion) in Caribbean small states in 2002 and the CO2 emissions (% of total fuel combustion) in Italy in 2003?
Provide a succinct answer. -1.74. What is the difference between the CO2 emissions (% of total fuel combustion) in High income: OECD in 2002 and the CO2 emissions (% of total fuel combustion) in Greece in 2003?
Provide a succinct answer. -1.7. What is the difference between the CO2 emissions (% of total fuel combustion) of High income: OECD in 2002 and the CO2 emissions (% of total fuel combustion) of Italy in 2003?
Provide a short and direct response. -0.47. What is the difference between the CO2 emissions (% of total fuel combustion) in Greece in 2002 and the CO2 emissions (% of total fuel combustion) in Italy in 2003?
Ensure brevity in your answer.  1.15. What is the difference between the CO2 emissions (% of total fuel combustion) in Caribbean small states in 2002 and the CO2 emissions (% of total fuel combustion) in High income: OECD in 2004?
Your response must be concise. -1.24. What is the difference between the CO2 emissions (% of total fuel combustion) in Caribbean small states in 2002 and the CO2 emissions (% of total fuel combustion) in Greece in 2004?
Your answer should be very brief. -2.5. What is the difference between the CO2 emissions (% of total fuel combustion) in Caribbean small states in 2002 and the CO2 emissions (% of total fuel combustion) in Italy in 2004?
Make the answer very short. -1.71. What is the difference between the CO2 emissions (% of total fuel combustion) of High income: OECD in 2002 and the CO2 emissions (% of total fuel combustion) of Greece in 2004?
Provide a succinct answer. -1.23. What is the difference between the CO2 emissions (% of total fuel combustion) in High income: OECD in 2002 and the CO2 emissions (% of total fuel combustion) in Italy in 2004?
Ensure brevity in your answer.  -0.44. What is the difference between the CO2 emissions (% of total fuel combustion) in Greece in 2002 and the CO2 emissions (% of total fuel combustion) in Italy in 2004?
Keep it short and to the point. 1.18. What is the difference between the CO2 emissions (% of total fuel combustion) of Caribbean small states in 2003 and the CO2 emissions (% of total fuel combustion) of High income: OECD in 2004?
Ensure brevity in your answer.  -1.27. What is the difference between the CO2 emissions (% of total fuel combustion) in Caribbean small states in 2003 and the CO2 emissions (% of total fuel combustion) in Greece in 2004?
Ensure brevity in your answer.  -2.53. What is the difference between the CO2 emissions (% of total fuel combustion) of Caribbean small states in 2003 and the CO2 emissions (% of total fuel combustion) of Italy in 2004?
Make the answer very short. -1.73. What is the difference between the CO2 emissions (% of total fuel combustion) of High income: OECD in 2003 and the CO2 emissions (% of total fuel combustion) of Greece in 2004?
Provide a succinct answer. -1.34. What is the difference between the CO2 emissions (% of total fuel combustion) in High income: OECD in 2003 and the CO2 emissions (% of total fuel combustion) in Italy in 2004?
Ensure brevity in your answer.  -0.54. What is the difference between the CO2 emissions (% of total fuel combustion) of Greece in 2003 and the CO2 emissions (% of total fuel combustion) of Italy in 2004?
Offer a terse response. 1.26. What is the average CO2 emissions (% of total fuel combustion) of Caribbean small states per year?
Your answer should be compact. 0.17. What is the average CO2 emissions (% of total fuel combustion) in High income: OECD per year?
Offer a very short reply. 1.6. What is the average CO2 emissions (% of total fuel combustion) of Greece per year?
Your answer should be very brief. 3.13. What is the average CO2 emissions (% of total fuel combustion) of Italy per year?
Provide a short and direct response. 2.2. In the year 1997, what is the difference between the CO2 emissions (% of total fuel combustion) in Caribbean small states and CO2 emissions (% of total fuel combustion) in High income: OECD?
Offer a terse response. -1.67. In the year 1997, what is the difference between the CO2 emissions (% of total fuel combustion) of Caribbean small states and CO2 emissions (% of total fuel combustion) of Greece?
Provide a succinct answer. -3.3. In the year 1997, what is the difference between the CO2 emissions (% of total fuel combustion) in Caribbean small states and CO2 emissions (% of total fuel combustion) in Italy?
Offer a terse response. -2.35. In the year 1997, what is the difference between the CO2 emissions (% of total fuel combustion) in High income: OECD and CO2 emissions (% of total fuel combustion) in Greece?
Your response must be concise. -1.64. In the year 1997, what is the difference between the CO2 emissions (% of total fuel combustion) of High income: OECD and CO2 emissions (% of total fuel combustion) of Italy?
Provide a succinct answer. -0.68. In the year 1997, what is the difference between the CO2 emissions (% of total fuel combustion) of Greece and CO2 emissions (% of total fuel combustion) of Italy?
Keep it short and to the point. 0.95. In the year 1998, what is the difference between the CO2 emissions (% of total fuel combustion) in Caribbean small states and CO2 emissions (% of total fuel combustion) in High income: OECD?
Your response must be concise. -1.6. In the year 1998, what is the difference between the CO2 emissions (% of total fuel combustion) in Caribbean small states and CO2 emissions (% of total fuel combustion) in Greece?
Offer a terse response. -3.16. In the year 1998, what is the difference between the CO2 emissions (% of total fuel combustion) of Caribbean small states and CO2 emissions (% of total fuel combustion) of Italy?
Give a very brief answer. -2.31. In the year 1998, what is the difference between the CO2 emissions (% of total fuel combustion) of High income: OECD and CO2 emissions (% of total fuel combustion) of Greece?
Ensure brevity in your answer.  -1.56. In the year 1998, what is the difference between the CO2 emissions (% of total fuel combustion) of High income: OECD and CO2 emissions (% of total fuel combustion) of Italy?
Give a very brief answer. -0.71. In the year 1998, what is the difference between the CO2 emissions (% of total fuel combustion) of Greece and CO2 emissions (% of total fuel combustion) of Italy?
Ensure brevity in your answer.  0.85. In the year 1999, what is the difference between the CO2 emissions (% of total fuel combustion) of Caribbean small states and CO2 emissions (% of total fuel combustion) of High income: OECD?
Ensure brevity in your answer.  -1.55. In the year 1999, what is the difference between the CO2 emissions (% of total fuel combustion) in Caribbean small states and CO2 emissions (% of total fuel combustion) in Greece?
Offer a very short reply. -3.17. In the year 1999, what is the difference between the CO2 emissions (% of total fuel combustion) of Caribbean small states and CO2 emissions (% of total fuel combustion) of Italy?
Your response must be concise. -2.23. In the year 1999, what is the difference between the CO2 emissions (% of total fuel combustion) of High income: OECD and CO2 emissions (% of total fuel combustion) of Greece?
Your response must be concise. -1.62. In the year 1999, what is the difference between the CO2 emissions (% of total fuel combustion) of High income: OECD and CO2 emissions (% of total fuel combustion) of Italy?
Your answer should be compact. -0.68. In the year 1999, what is the difference between the CO2 emissions (% of total fuel combustion) in Greece and CO2 emissions (% of total fuel combustion) in Italy?
Provide a succinct answer. 0.94. In the year 2000, what is the difference between the CO2 emissions (% of total fuel combustion) of Caribbean small states and CO2 emissions (% of total fuel combustion) of High income: OECD?
Your response must be concise. -1.55. In the year 2000, what is the difference between the CO2 emissions (% of total fuel combustion) of Caribbean small states and CO2 emissions (% of total fuel combustion) of Greece?
Provide a succinct answer. -2.94. In the year 2000, what is the difference between the CO2 emissions (% of total fuel combustion) of Caribbean small states and CO2 emissions (% of total fuel combustion) of Italy?
Keep it short and to the point. -2.12. In the year 2000, what is the difference between the CO2 emissions (% of total fuel combustion) of High income: OECD and CO2 emissions (% of total fuel combustion) of Greece?
Offer a terse response. -1.39. In the year 2000, what is the difference between the CO2 emissions (% of total fuel combustion) of High income: OECD and CO2 emissions (% of total fuel combustion) of Italy?
Your answer should be compact. -0.58. In the year 2000, what is the difference between the CO2 emissions (% of total fuel combustion) of Greece and CO2 emissions (% of total fuel combustion) of Italy?
Give a very brief answer. 0.81. In the year 2001, what is the difference between the CO2 emissions (% of total fuel combustion) in Caribbean small states and CO2 emissions (% of total fuel combustion) in High income: OECD?
Offer a terse response. -1.51. In the year 2001, what is the difference between the CO2 emissions (% of total fuel combustion) in Caribbean small states and CO2 emissions (% of total fuel combustion) in Greece?
Give a very brief answer. -2.88. In the year 2001, what is the difference between the CO2 emissions (% of total fuel combustion) of Caribbean small states and CO2 emissions (% of total fuel combustion) of Italy?
Give a very brief answer. -2.08. In the year 2001, what is the difference between the CO2 emissions (% of total fuel combustion) in High income: OECD and CO2 emissions (% of total fuel combustion) in Greece?
Your answer should be very brief. -1.37. In the year 2001, what is the difference between the CO2 emissions (% of total fuel combustion) in High income: OECD and CO2 emissions (% of total fuel combustion) in Italy?
Your answer should be compact. -0.57. In the year 2001, what is the difference between the CO2 emissions (% of total fuel combustion) of Greece and CO2 emissions (% of total fuel combustion) of Italy?
Provide a succinct answer. 0.8. In the year 2002, what is the difference between the CO2 emissions (% of total fuel combustion) of Caribbean small states and CO2 emissions (% of total fuel combustion) of High income: OECD?
Give a very brief answer. -1.27. In the year 2002, what is the difference between the CO2 emissions (% of total fuel combustion) in Caribbean small states and CO2 emissions (% of total fuel combustion) in Greece?
Provide a short and direct response. -2.89. In the year 2002, what is the difference between the CO2 emissions (% of total fuel combustion) in Caribbean small states and CO2 emissions (% of total fuel combustion) in Italy?
Provide a short and direct response. -1.77. In the year 2002, what is the difference between the CO2 emissions (% of total fuel combustion) in High income: OECD and CO2 emissions (% of total fuel combustion) in Greece?
Your answer should be very brief. -1.62. In the year 2002, what is the difference between the CO2 emissions (% of total fuel combustion) in High income: OECD and CO2 emissions (% of total fuel combustion) in Italy?
Provide a short and direct response. -0.5. In the year 2002, what is the difference between the CO2 emissions (% of total fuel combustion) in Greece and CO2 emissions (% of total fuel combustion) in Italy?
Your answer should be very brief. 1.12. In the year 2003, what is the difference between the CO2 emissions (% of total fuel combustion) of Caribbean small states and CO2 emissions (% of total fuel combustion) of High income: OECD?
Your response must be concise. -1.19. In the year 2003, what is the difference between the CO2 emissions (% of total fuel combustion) in Caribbean small states and CO2 emissions (% of total fuel combustion) in Greece?
Make the answer very short. -3. In the year 2003, what is the difference between the CO2 emissions (% of total fuel combustion) in Caribbean small states and CO2 emissions (% of total fuel combustion) in Italy?
Make the answer very short. -1.77. In the year 2003, what is the difference between the CO2 emissions (% of total fuel combustion) of High income: OECD and CO2 emissions (% of total fuel combustion) of Greece?
Offer a terse response. -1.8. In the year 2003, what is the difference between the CO2 emissions (% of total fuel combustion) in High income: OECD and CO2 emissions (% of total fuel combustion) in Italy?
Offer a terse response. -0.57. In the year 2003, what is the difference between the CO2 emissions (% of total fuel combustion) in Greece and CO2 emissions (% of total fuel combustion) in Italy?
Your response must be concise. 1.23. In the year 2004, what is the difference between the CO2 emissions (% of total fuel combustion) in Caribbean small states and CO2 emissions (% of total fuel combustion) in High income: OECD?
Your answer should be very brief. -1.09. In the year 2004, what is the difference between the CO2 emissions (% of total fuel combustion) in Caribbean small states and CO2 emissions (% of total fuel combustion) in Greece?
Provide a succinct answer. -2.35. In the year 2004, what is the difference between the CO2 emissions (% of total fuel combustion) in Caribbean small states and CO2 emissions (% of total fuel combustion) in Italy?
Keep it short and to the point. -1.56. In the year 2004, what is the difference between the CO2 emissions (% of total fuel combustion) in High income: OECD and CO2 emissions (% of total fuel combustion) in Greece?
Offer a terse response. -1.26. In the year 2004, what is the difference between the CO2 emissions (% of total fuel combustion) of High income: OECD and CO2 emissions (% of total fuel combustion) of Italy?
Your response must be concise. -0.47. In the year 2004, what is the difference between the CO2 emissions (% of total fuel combustion) in Greece and CO2 emissions (% of total fuel combustion) in Italy?
Ensure brevity in your answer.  0.79. What is the ratio of the CO2 emissions (% of total fuel combustion) of Caribbean small states in 1997 to that in 1998?
Provide a succinct answer. 1.1. What is the ratio of the CO2 emissions (% of total fuel combustion) of High income: OECD in 1997 to that in 1998?
Offer a terse response. 1.04. What is the ratio of the CO2 emissions (% of total fuel combustion) of Greece in 1997 to that in 1998?
Make the answer very short. 1.05. What is the ratio of the CO2 emissions (% of total fuel combustion) of Italy in 1997 to that in 1998?
Your answer should be very brief. 1.02. What is the ratio of the CO2 emissions (% of total fuel combustion) of Caribbean small states in 1997 to that in 1999?
Offer a very short reply. 1.15. What is the ratio of the CO2 emissions (% of total fuel combustion) in High income: OECD in 1997 to that in 1999?
Your response must be concise. 1.08. What is the ratio of the CO2 emissions (% of total fuel combustion) in Greece in 1997 to that in 1999?
Provide a short and direct response. 1.04. What is the ratio of the CO2 emissions (% of total fuel combustion) in Italy in 1997 to that in 1999?
Provide a succinct answer. 1.06. What is the ratio of the CO2 emissions (% of total fuel combustion) in Caribbean small states in 1997 to that in 2000?
Provide a succinct answer. 2.37. What is the ratio of the CO2 emissions (% of total fuel combustion) in High income: OECD in 1997 to that in 2000?
Ensure brevity in your answer.  1.11. What is the ratio of the CO2 emissions (% of total fuel combustion) in Greece in 1997 to that in 2000?
Ensure brevity in your answer.  1.14. What is the ratio of the CO2 emissions (% of total fuel combustion) of Italy in 1997 to that in 2000?
Give a very brief answer. 1.13. What is the ratio of the CO2 emissions (% of total fuel combustion) in Caribbean small states in 1997 to that in 2001?
Your answer should be compact. 1.3. What is the ratio of the CO2 emissions (% of total fuel combustion) of High income: OECD in 1997 to that in 2001?
Ensure brevity in your answer.  1.11. What is the ratio of the CO2 emissions (% of total fuel combustion) of Greece in 1997 to that in 2001?
Make the answer very short. 1.15. What is the ratio of the CO2 emissions (% of total fuel combustion) of Italy in 1997 to that in 2001?
Offer a very short reply. 1.13. What is the ratio of the CO2 emissions (% of total fuel combustion) of Caribbean small states in 1997 to that in 2002?
Your answer should be very brief. 0.28. What is the ratio of the CO2 emissions (% of total fuel combustion) in High income: OECD in 1997 to that in 2002?
Provide a succinct answer. 1.11. What is the ratio of the CO2 emissions (% of total fuel combustion) of Greece in 1997 to that in 2002?
Keep it short and to the point. 1.06. What is the ratio of the CO2 emissions (% of total fuel combustion) in Italy in 1997 to that in 2002?
Make the answer very short. 1.17. What is the ratio of the CO2 emissions (% of total fuel combustion) of Caribbean small states in 1997 to that in 2003?
Your answer should be compact. 0.3. What is the ratio of the CO2 emissions (% of total fuel combustion) of High income: OECD in 1997 to that in 2003?
Keep it short and to the point. 1.19. What is the ratio of the CO2 emissions (% of total fuel combustion) in Greece in 1997 to that in 2003?
Ensure brevity in your answer.  1.03. What is the ratio of the CO2 emissions (% of total fuel combustion) of Italy in 1997 to that in 2003?
Give a very brief answer. 1.19. What is the ratio of the CO2 emissions (% of total fuel combustion) in Caribbean small states in 1997 to that in 2004?
Offer a terse response. 0.19. What is the ratio of the CO2 emissions (% of total fuel combustion) of High income: OECD in 1997 to that in 2004?
Give a very brief answer. 1.13. What is the ratio of the CO2 emissions (% of total fuel combustion) in Greece in 1997 to that in 2004?
Keep it short and to the point. 1.21. What is the ratio of the CO2 emissions (% of total fuel combustion) in Italy in 1997 to that in 2004?
Provide a succinct answer. 1.21. What is the ratio of the CO2 emissions (% of total fuel combustion) of Caribbean small states in 1998 to that in 1999?
Your response must be concise. 1.04. What is the ratio of the CO2 emissions (% of total fuel combustion) of High income: OECD in 1998 to that in 1999?
Offer a very short reply. 1.03. What is the ratio of the CO2 emissions (% of total fuel combustion) of Greece in 1998 to that in 1999?
Offer a very short reply. 1. What is the ratio of the CO2 emissions (% of total fuel combustion) of Italy in 1998 to that in 1999?
Ensure brevity in your answer.  1.04. What is the ratio of the CO2 emissions (% of total fuel combustion) of Caribbean small states in 1998 to that in 2000?
Your response must be concise. 2.16. What is the ratio of the CO2 emissions (% of total fuel combustion) in High income: OECD in 1998 to that in 2000?
Your answer should be very brief. 1.06. What is the ratio of the CO2 emissions (% of total fuel combustion) in Greece in 1998 to that in 2000?
Make the answer very short. 1.09. What is the ratio of the CO2 emissions (% of total fuel combustion) of Italy in 1998 to that in 2000?
Offer a terse response. 1.1. What is the ratio of the CO2 emissions (% of total fuel combustion) in Caribbean small states in 1998 to that in 2001?
Your answer should be compact. 1.18. What is the ratio of the CO2 emissions (% of total fuel combustion) of High income: OECD in 1998 to that in 2001?
Ensure brevity in your answer.  1.06. What is the ratio of the CO2 emissions (% of total fuel combustion) of Greece in 1998 to that in 2001?
Ensure brevity in your answer.  1.1. What is the ratio of the CO2 emissions (% of total fuel combustion) of Italy in 1998 to that in 2001?
Provide a succinct answer. 1.11. What is the ratio of the CO2 emissions (% of total fuel combustion) in Caribbean small states in 1998 to that in 2002?
Offer a terse response. 0.25. What is the ratio of the CO2 emissions (% of total fuel combustion) of High income: OECD in 1998 to that in 2002?
Your response must be concise. 1.06. What is the ratio of the CO2 emissions (% of total fuel combustion) of Greece in 1998 to that in 2002?
Your answer should be compact. 1.01. What is the ratio of the CO2 emissions (% of total fuel combustion) in Italy in 1998 to that in 2002?
Provide a short and direct response. 1.15. What is the ratio of the CO2 emissions (% of total fuel combustion) of Caribbean small states in 1998 to that in 2003?
Provide a succinct answer. 0.28. What is the ratio of the CO2 emissions (% of total fuel combustion) in High income: OECD in 1998 to that in 2003?
Your response must be concise. 1.14. What is the ratio of the CO2 emissions (% of total fuel combustion) in Greece in 1998 to that in 2003?
Your answer should be compact. 0.99. What is the ratio of the CO2 emissions (% of total fuel combustion) of Italy in 1998 to that in 2003?
Your response must be concise. 1.17. What is the ratio of the CO2 emissions (% of total fuel combustion) in Caribbean small states in 1998 to that in 2004?
Provide a succinct answer. 0.17. What is the ratio of the CO2 emissions (% of total fuel combustion) of High income: OECD in 1998 to that in 2004?
Keep it short and to the point. 1.08. What is the ratio of the CO2 emissions (% of total fuel combustion) of Greece in 1998 to that in 2004?
Make the answer very short. 1.15. What is the ratio of the CO2 emissions (% of total fuel combustion) of Italy in 1998 to that in 2004?
Keep it short and to the point. 1.18. What is the ratio of the CO2 emissions (% of total fuel combustion) in Caribbean small states in 1999 to that in 2000?
Provide a succinct answer. 2.07. What is the ratio of the CO2 emissions (% of total fuel combustion) of High income: OECD in 1999 to that in 2000?
Your answer should be compact. 1.02. What is the ratio of the CO2 emissions (% of total fuel combustion) in Greece in 1999 to that in 2000?
Your answer should be compact. 1.09. What is the ratio of the CO2 emissions (% of total fuel combustion) in Italy in 1999 to that in 2000?
Ensure brevity in your answer.  1.07. What is the ratio of the CO2 emissions (% of total fuel combustion) in Caribbean small states in 1999 to that in 2001?
Offer a terse response. 1.13. What is the ratio of the CO2 emissions (% of total fuel combustion) in High income: OECD in 1999 to that in 2001?
Your answer should be very brief. 1.03. What is the ratio of the CO2 emissions (% of total fuel combustion) of Greece in 1999 to that in 2001?
Offer a terse response. 1.1. What is the ratio of the CO2 emissions (% of total fuel combustion) in Italy in 1999 to that in 2001?
Your answer should be very brief. 1.07. What is the ratio of the CO2 emissions (% of total fuel combustion) of Caribbean small states in 1999 to that in 2002?
Provide a short and direct response. 0.24. What is the ratio of the CO2 emissions (% of total fuel combustion) in High income: OECD in 1999 to that in 2002?
Provide a short and direct response. 1.03. What is the ratio of the CO2 emissions (% of total fuel combustion) of Greece in 1999 to that in 2002?
Provide a short and direct response. 1.02. What is the ratio of the CO2 emissions (% of total fuel combustion) in Italy in 1999 to that in 2002?
Provide a short and direct response. 1.11. What is the ratio of the CO2 emissions (% of total fuel combustion) of Caribbean small states in 1999 to that in 2003?
Your answer should be very brief. 0.26. What is the ratio of the CO2 emissions (% of total fuel combustion) in High income: OECD in 1999 to that in 2003?
Provide a short and direct response. 1.1. What is the ratio of the CO2 emissions (% of total fuel combustion) in Greece in 1999 to that in 2003?
Make the answer very short. 0.99. What is the ratio of the CO2 emissions (% of total fuel combustion) of Italy in 1999 to that in 2003?
Offer a very short reply. 1.12. What is the ratio of the CO2 emissions (% of total fuel combustion) in Caribbean small states in 1999 to that in 2004?
Ensure brevity in your answer.  0.16. What is the ratio of the CO2 emissions (% of total fuel combustion) in High income: OECD in 1999 to that in 2004?
Your answer should be very brief. 1.05. What is the ratio of the CO2 emissions (% of total fuel combustion) of Greece in 1999 to that in 2004?
Ensure brevity in your answer.  1.16. What is the ratio of the CO2 emissions (% of total fuel combustion) of Italy in 1999 to that in 2004?
Your answer should be compact. 1.14. What is the ratio of the CO2 emissions (% of total fuel combustion) in Caribbean small states in 2000 to that in 2001?
Keep it short and to the point. 0.55. What is the ratio of the CO2 emissions (% of total fuel combustion) of Greece in 2000 to that in 2001?
Offer a very short reply. 1.01. What is the ratio of the CO2 emissions (% of total fuel combustion) in Italy in 2000 to that in 2001?
Your response must be concise. 1.01. What is the ratio of the CO2 emissions (% of total fuel combustion) in Caribbean small states in 2000 to that in 2002?
Your response must be concise. 0.12. What is the ratio of the CO2 emissions (% of total fuel combustion) of Greece in 2000 to that in 2002?
Offer a very short reply. 0.93. What is the ratio of the CO2 emissions (% of total fuel combustion) in Italy in 2000 to that in 2002?
Make the answer very short. 1.04. What is the ratio of the CO2 emissions (% of total fuel combustion) in Caribbean small states in 2000 to that in 2003?
Offer a terse response. 0.13. What is the ratio of the CO2 emissions (% of total fuel combustion) of High income: OECD in 2000 to that in 2003?
Provide a succinct answer. 1.08. What is the ratio of the CO2 emissions (% of total fuel combustion) in Greece in 2000 to that in 2003?
Your answer should be very brief. 0.91. What is the ratio of the CO2 emissions (% of total fuel combustion) of Italy in 2000 to that in 2003?
Your answer should be compact. 1.06. What is the ratio of the CO2 emissions (% of total fuel combustion) of Caribbean small states in 2000 to that in 2004?
Make the answer very short. 0.08. What is the ratio of the CO2 emissions (% of total fuel combustion) in High income: OECD in 2000 to that in 2004?
Offer a terse response. 1.02. What is the ratio of the CO2 emissions (% of total fuel combustion) in Greece in 2000 to that in 2004?
Make the answer very short. 1.06. What is the ratio of the CO2 emissions (% of total fuel combustion) in Italy in 2000 to that in 2004?
Your response must be concise. 1.07. What is the ratio of the CO2 emissions (% of total fuel combustion) of Caribbean small states in 2001 to that in 2002?
Ensure brevity in your answer.  0.21. What is the ratio of the CO2 emissions (% of total fuel combustion) of Greece in 2001 to that in 2002?
Your answer should be very brief. 0.92. What is the ratio of the CO2 emissions (% of total fuel combustion) in Italy in 2001 to that in 2002?
Your answer should be very brief. 1.03. What is the ratio of the CO2 emissions (% of total fuel combustion) in Caribbean small states in 2001 to that in 2003?
Your answer should be very brief. 0.23. What is the ratio of the CO2 emissions (% of total fuel combustion) in High income: OECD in 2001 to that in 2003?
Give a very brief answer. 1.07. What is the ratio of the CO2 emissions (% of total fuel combustion) in Greece in 2001 to that in 2003?
Provide a succinct answer. 0.9. What is the ratio of the CO2 emissions (% of total fuel combustion) of Italy in 2001 to that in 2003?
Offer a terse response. 1.05. What is the ratio of the CO2 emissions (% of total fuel combustion) of Caribbean small states in 2001 to that in 2004?
Keep it short and to the point. 0.14. What is the ratio of the CO2 emissions (% of total fuel combustion) in High income: OECD in 2001 to that in 2004?
Your response must be concise. 1.02. What is the ratio of the CO2 emissions (% of total fuel combustion) in Greece in 2001 to that in 2004?
Offer a very short reply. 1.05. What is the ratio of the CO2 emissions (% of total fuel combustion) in Italy in 2001 to that in 2004?
Provide a succinct answer. 1.06. What is the ratio of the CO2 emissions (% of total fuel combustion) of Caribbean small states in 2002 to that in 2003?
Your answer should be very brief. 1.09. What is the ratio of the CO2 emissions (% of total fuel combustion) in High income: OECD in 2002 to that in 2003?
Offer a terse response. 1.07. What is the ratio of the CO2 emissions (% of total fuel combustion) in Greece in 2002 to that in 2003?
Give a very brief answer. 0.97. What is the ratio of the CO2 emissions (% of total fuel combustion) in Italy in 2002 to that in 2003?
Keep it short and to the point. 1.02. What is the ratio of the CO2 emissions (% of total fuel combustion) of Caribbean small states in 2002 to that in 2004?
Provide a short and direct response. 0.68. What is the ratio of the CO2 emissions (% of total fuel combustion) of High income: OECD in 2002 to that in 2004?
Provide a short and direct response. 1.02. What is the ratio of the CO2 emissions (% of total fuel combustion) in Greece in 2002 to that in 2004?
Ensure brevity in your answer.  1.14. What is the ratio of the CO2 emissions (% of total fuel combustion) in Italy in 2002 to that in 2004?
Your answer should be very brief. 1.03. What is the ratio of the CO2 emissions (% of total fuel combustion) in Caribbean small states in 2003 to that in 2004?
Make the answer very short. 0.62. What is the ratio of the CO2 emissions (% of total fuel combustion) in High income: OECD in 2003 to that in 2004?
Provide a short and direct response. 0.95. What is the ratio of the CO2 emissions (% of total fuel combustion) of Greece in 2003 to that in 2004?
Provide a short and direct response. 1.17. What is the ratio of the CO2 emissions (% of total fuel combustion) in Italy in 2003 to that in 2004?
Provide a short and direct response. 1.02. What is the difference between the highest and the second highest CO2 emissions (% of total fuel combustion) in Caribbean small states?
Make the answer very short. 0.15. What is the difference between the highest and the second highest CO2 emissions (% of total fuel combustion) in High income: OECD?
Give a very brief answer. 0.07. What is the difference between the highest and the second highest CO2 emissions (% of total fuel combustion) of Greece?
Make the answer very short. 0.11. What is the difference between the highest and the second highest CO2 emissions (% of total fuel combustion) in Italy?
Provide a short and direct response. 0.05. What is the difference between the highest and the lowest CO2 emissions (% of total fuel combustion) of Caribbean small states?
Offer a terse response. 0.42. What is the difference between the highest and the lowest CO2 emissions (% of total fuel combustion) of High income: OECD?
Ensure brevity in your answer.  0.28. What is the difference between the highest and the lowest CO2 emissions (% of total fuel combustion) of Greece?
Keep it short and to the point. 0.58. What is the difference between the highest and the lowest CO2 emissions (% of total fuel combustion) of Italy?
Keep it short and to the point. 0.42. 